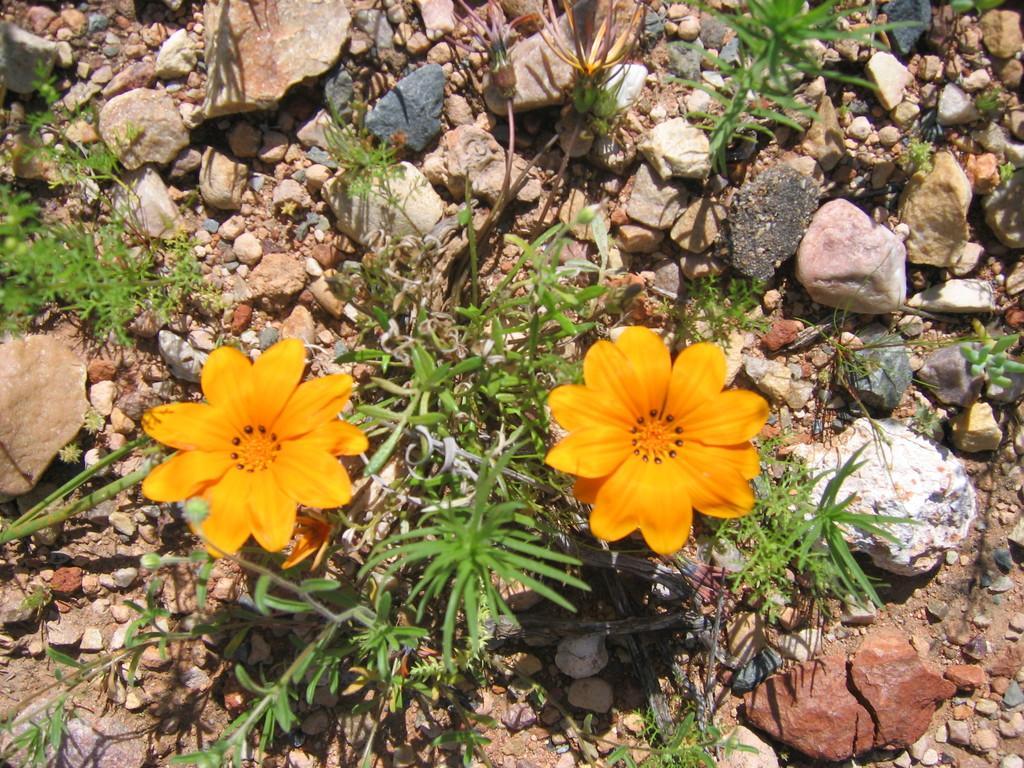How would you summarize this image in a sentence or two? In this image we can see there are plants, flowers and stones. 